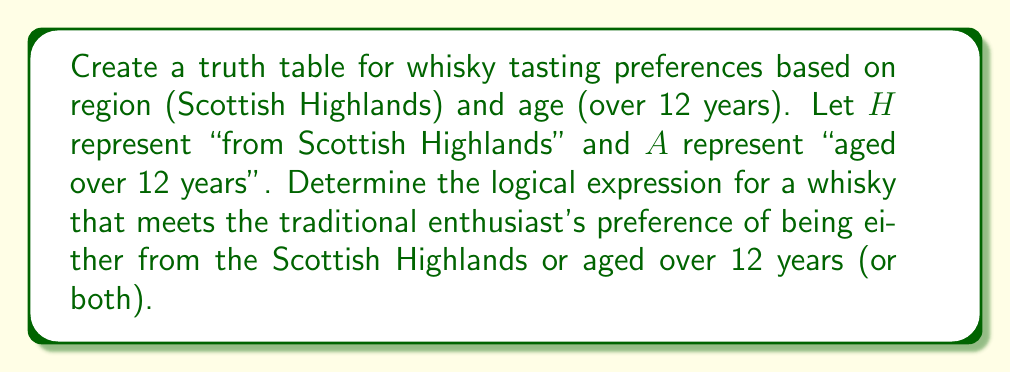What is the answer to this math problem? 1. First, let's create the truth table with inputs $H$ and $A$:

   | $H$ | $A$ | Output |
   |-----|-----|--------|
   | 0   | 0   | 0      |
   | 0   | 1   | 1      |
   | 1   | 0   | 1      |
   | 1   | 1   | 1      |

2. The output is 1 (true) when either $H$ or $A$ (or both) are true, which corresponds to the logical OR operation.

3. The logical expression for this preference can be written as:

   $$ H \lor A $$

   Where $\lor$ represents the logical OR operation.

4. This expression accurately represents the traditional enthusiast's preference for whiskies that are either from the Scottish Highlands, aged over 12 years, or both.

5. We can verify this by checking each row of the truth table:
   - When both $H$ and $A$ are false (0), the output is false (0).
   - When either $H$ or $A$ (or both) are true (1), the output is true (1).

6. This logical expression encompasses all cases where the whisky meets at least one of the two criteria, aligning with the enthusiast's preference for traditional, unblended whiskies.
Answer: $H \lor A$ 